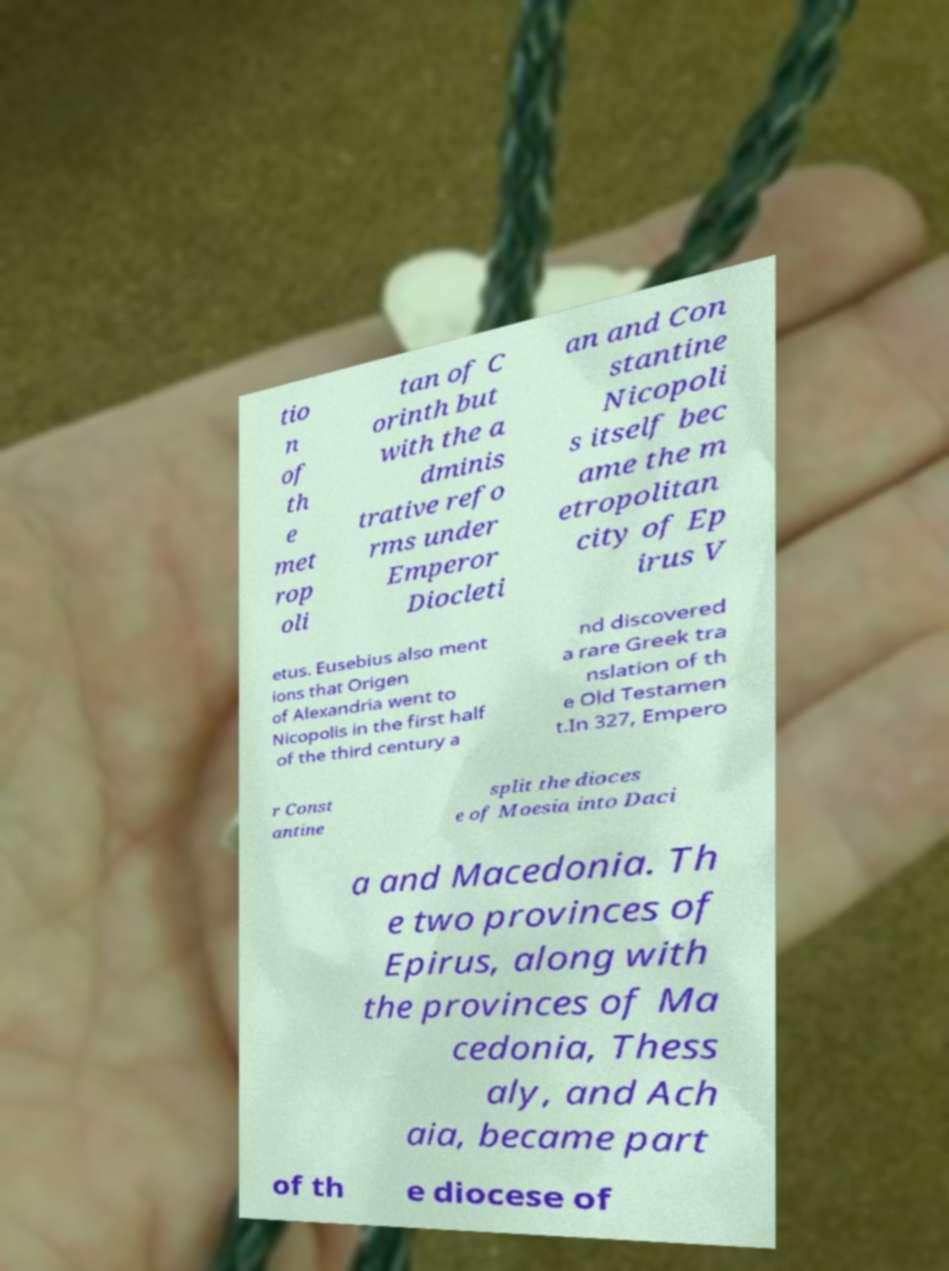What messages or text are displayed in this image? I need them in a readable, typed format. tio n of th e met rop oli tan of C orinth but with the a dminis trative refo rms under Emperor Diocleti an and Con stantine Nicopoli s itself bec ame the m etropolitan city of Ep irus V etus. Eusebius also ment ions that Origen of Alexandria went to Nicopolis in the first half of the third century a nd discovered a rare Greek tra nslation of th e Old Testamen t.In 327, Empero r Const antine split the dioces e of Moesia into Daci a and Macedonia. Th e two provinces of Epirus, along with the provinces of Ma cedonia, Thess aly, and Ach aia, became part of th e diocese of 